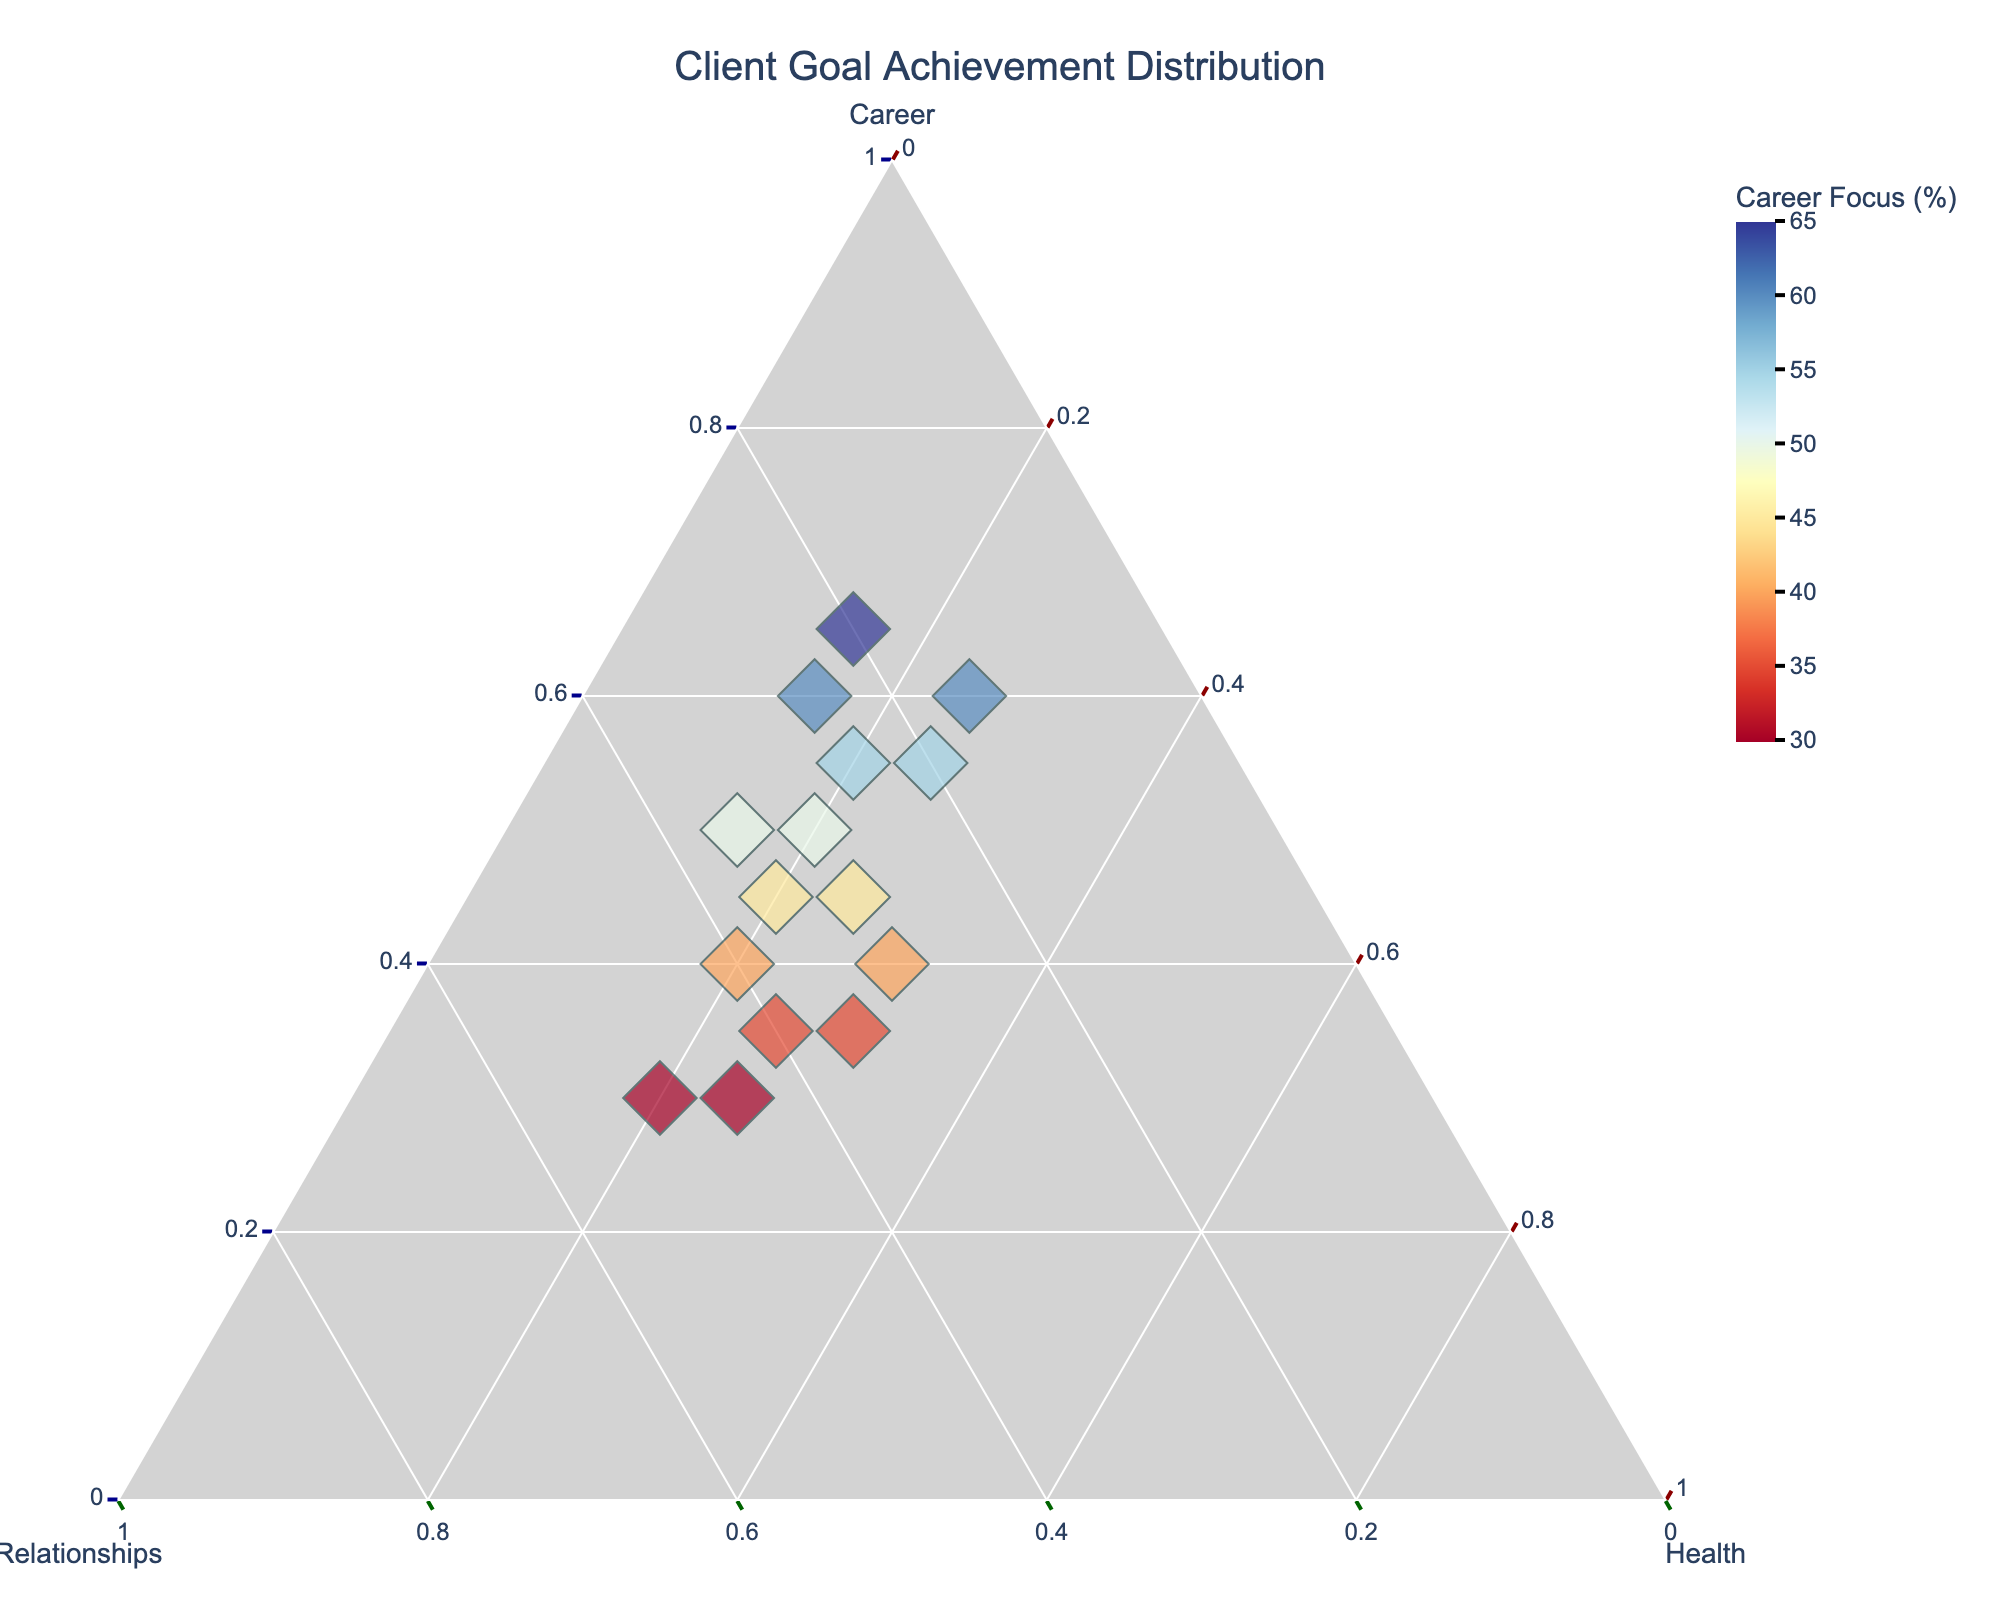What is the title of the plot? The plot's title is usually at the top and provides a summary of what the figure represents.
Answer: Client Goal Achievement Distribution What colors are used to represent the ranges of career focus percentage? The plot uses color to represent different ranges, which is indicated by a gradient bar.
Answer: A color scale from red to blue How many clients are displayed in the plot? Each point in the ternary plot represents a client, and by counting these points, we can determine the number of clients.
Answer: 15 Which client has the highest percentage of career development focus? Look for the point closest to the Career Development axis, as that would indicate the highest value in that dimension.
Answer: Jason Lee How does Sarah Johnson's focus on personal relationships compare to health improvement? Sarah Johnson's positions on the Personal Relationships and Health Improvement axes can be compared directly.
Answer: Personal Relationships is higher Which clients have the same percentage focus on health improvement? Identify points with the same value along the Health Improvement axis. Multiple clients can be cross-referenced with the data provided in the hover name section of the plot.
Answer: Michael Chen, David Thompson, Emily Rodriguez, and Olivia Martinez What is the most balanced focus among the three areas? A balanced focus would be closer to the center of the plot, equidistant from all three axes. Check for this characteristic.
Answer: Daniel Patel What is the primary focus area for most clients? Assess the spread of data points along the axes to determine which focus area has the most concentrated number of points.
Answer: Career Development Compare the focus areas for Olivia Martinez and Samantha White. Who has a higher focus on personal relationships? Look at the positions of Olivia Martinez and Samantha White on the Personal Relationships axis and compare them.
Answer: Samantha White 